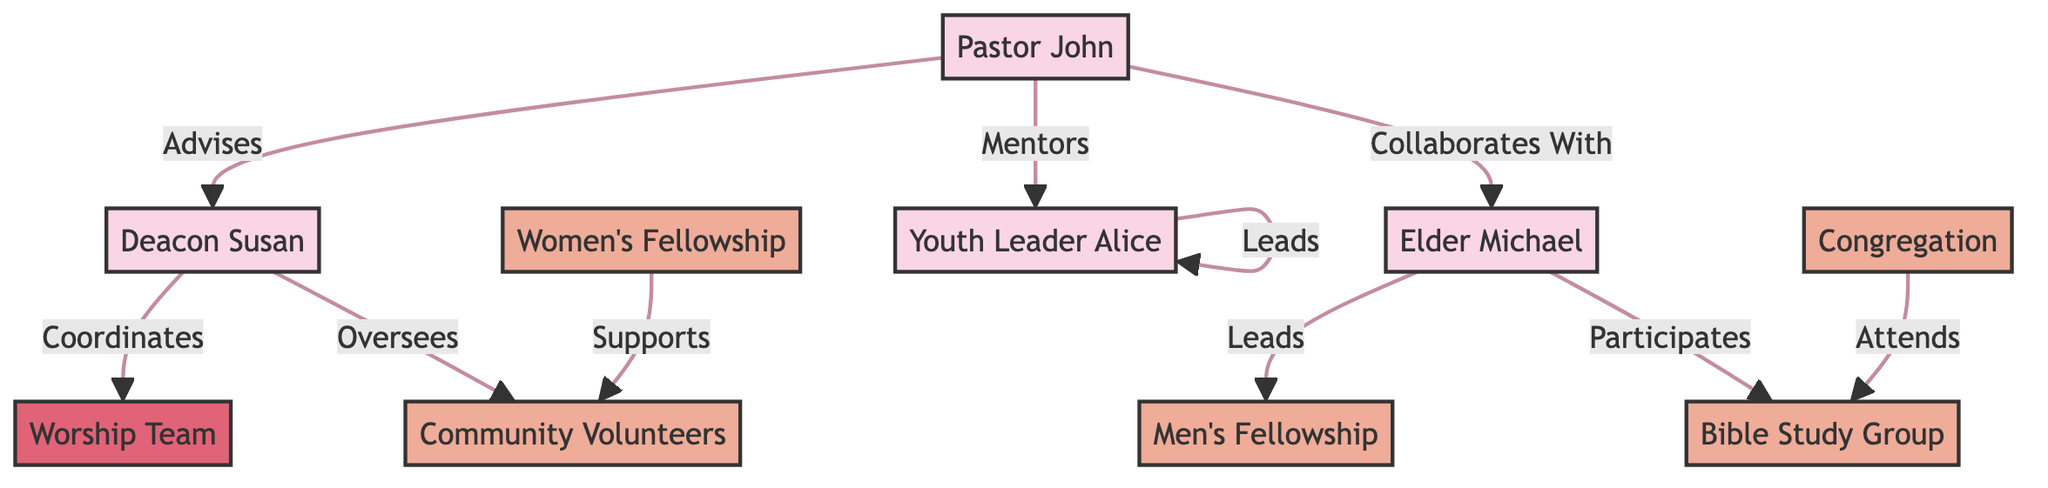What is the total number of nodes in the diagram? To find the number of nodes, count each distinct person or group represented in the diagram. The provided data lists 10 nodes: Pastor John, Deacon Susan, Elder Michael, Youth Leader Alice, Worship Team, Men's Fellowship, Women's Fellowship, Bible Study Group, Community Volunteers, and Congregation.
Answer: 10 Who advises Deacon Susan? The edges represent relationships between nodes. From the edge data, Pastor John is linked to Deacon Susan with the label "Advises," indicating that Pastor John advises her.
Answer: Pastor John What activity does Elder Michael lead? The relationships show that Elder Michael has a direct connection labeled "Leads" to Men's Fellowship. Thus, he leads this specific group.
Answer: Men's Fellowship How many relationships does Pastor John have? By examining the edges, we see that Pastor John is connected to three different nodes: Deacon Susan, Elder Michael, and Youth Leader Alice, indicating three relationships.
Answer: 3 Which group does Deacon Susan oversee? According to the edges, Deacon Susan has a direct relationship labeled "Oversees" with Community Volunteers, meaning she oversees this specific group.
Answer: Community Volunteers Which group is supported by Women's Fellowship? The diagram specifies a connection from Women's Fellowship to Community Volunteers with the label "Supports," indicating that Women's Fellowship supports this group.
Answer: Community Volunteers List one role of Youth Leader Alice. The edge data indicates that Youth Leader Alice has a self-loop labeled "Leads," which signifies that she is in a leadership role in her group.
Answer: Leads What is the connection between the Congregation and Bible Study Group? The relationship is established through the edge labeled "Attends," showing that the Congregation attends the Bible Study Group.
Answer: Attends Which leader collaborates with Elder Michael? Looking at the edges, Pastor John and Elder Michael have a connection labeled "Collaborates With." This indicates that Pastor John collaborates with Elder Michael.
Answer: Pastor John 